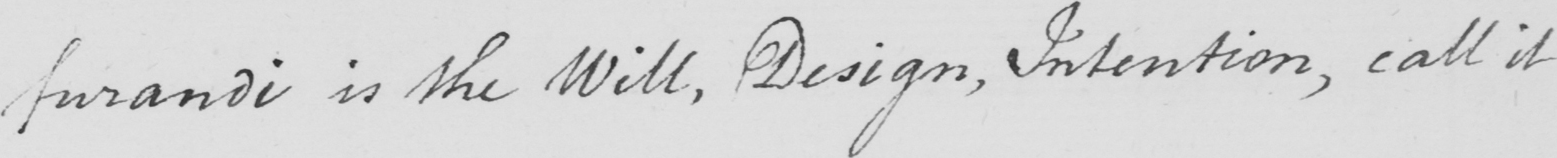What is written in this line of handwriting? furandi is the Will , Design , Intention , call it 